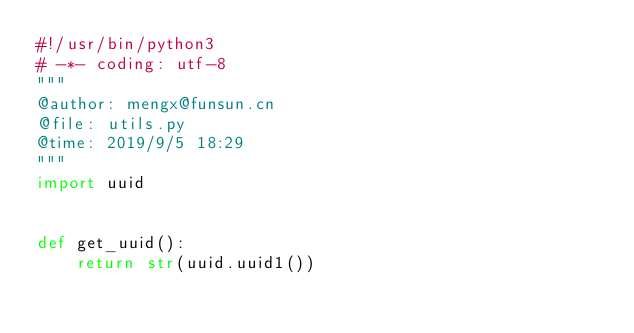<code> <loc_0><loc_0><loc_500><loc_500><_Python_>#!/usr/bin/python3
# -*- coding: utf-8
""" 
@author: mengx@funsun.cn 
@file: utils.py
@time: 2019/9/5 18:29
"""
import uuid


def get_uuid():
    return str(uuid.uuid1())
</code> 